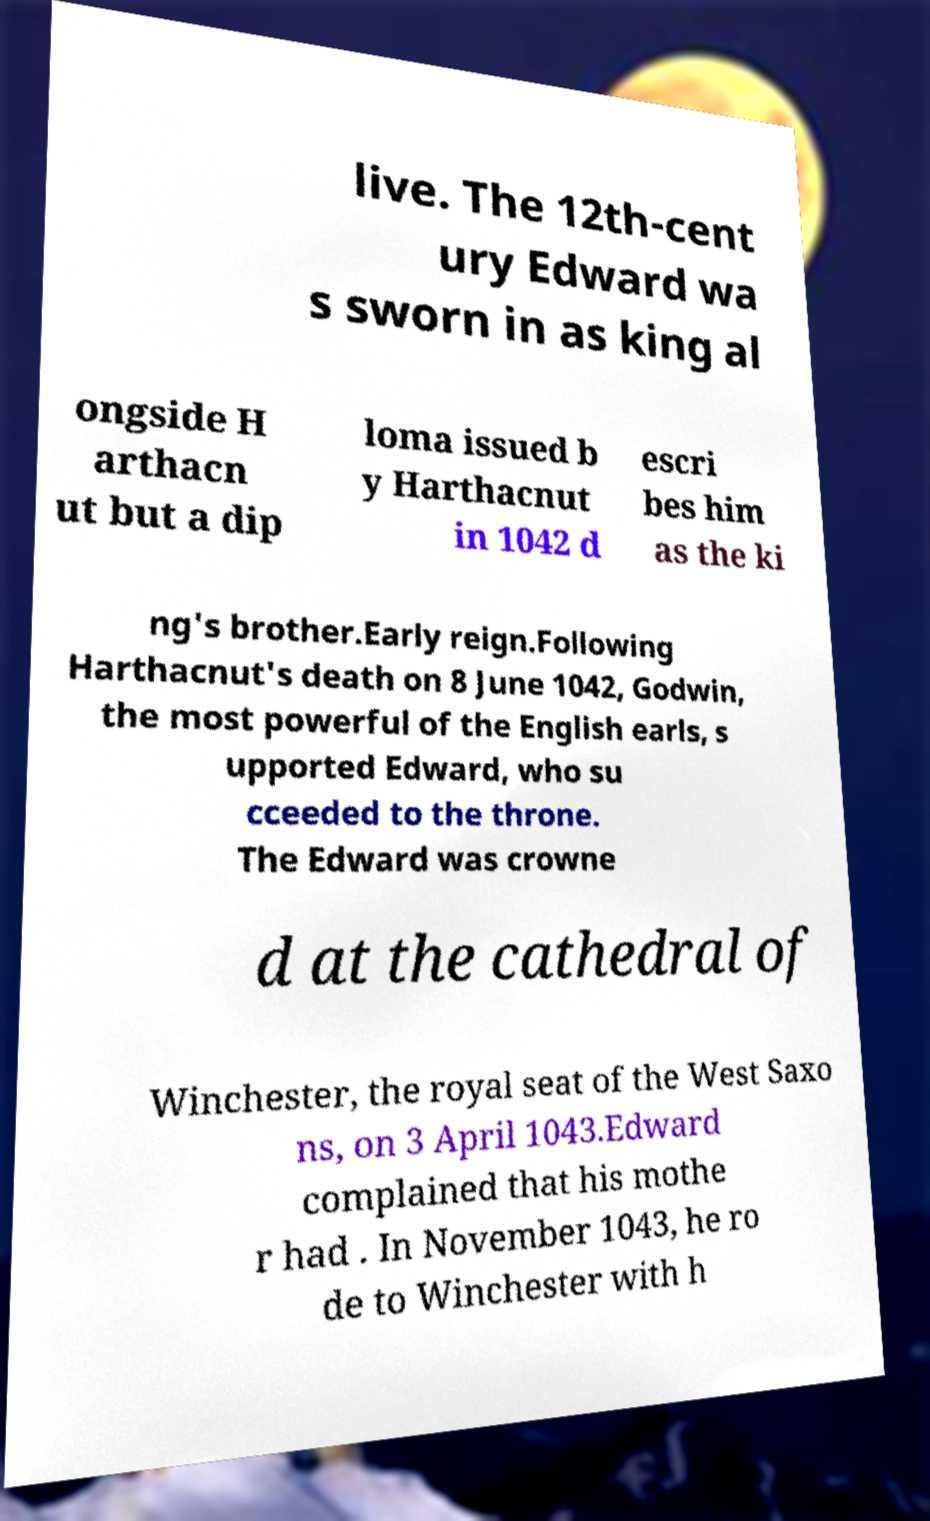Please identify and transcribe the text found in this image. live. The 12th-cent ury Edward wa s sworn in as king al ongside H arthacn ut but a dip loma issued b y Harthacnut in 1042 d escri bes him as the ki ng's brother.Early reign.Following Harthacnut's death on 8 June 1042, Godwin, the most powerful of the English earls, s upported Edward, who su cceeded to the throne. The Edward was crowne d at the cathedral of Winchester, the royal seat of the West Saxo ns, on 3 April 1043.Edward complained that his mothe r had . In November 1043, he ro de to Winchester with h 